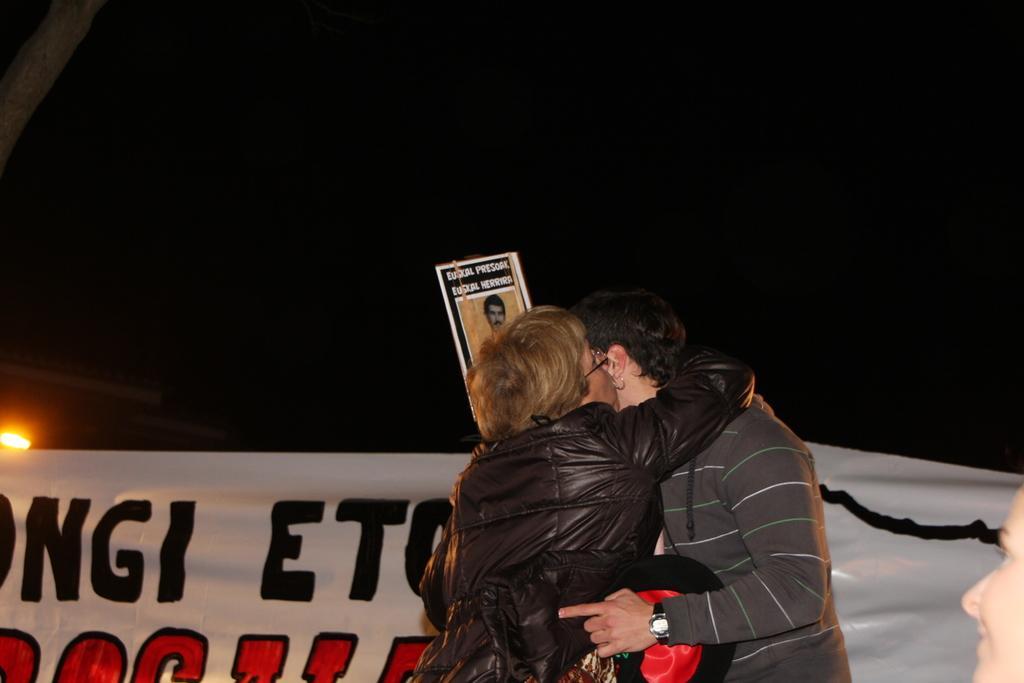Could you give a brief overview of what you see in this image? In this picture we can see three people, banner, poster, light, some objects and in the background it is dark. 